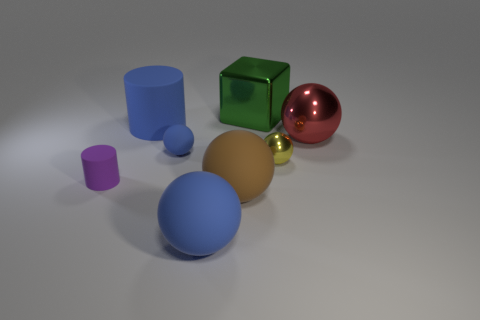There is a cylinder to the right of the purple matte cylinder; is its color the same as the tiny rubber ball?
Provide a short and direct response. Yes. There is a yellow thing that is the same shape as the small blue object; what is its size?
Provide a short and direct response. Small. What color is the big metallic thing that is on the left side of the small ball right of the blue ball in front of the large brown rubber ball?
Keep it short and to the point. Green. Are the brown sphere and the purple cylinder made of the same material?
Ensure brevity in your answer.  Yes. There is a blue sphere that is left of the blue object in front of the tiny blue matte thing; are there any cylinders in front of it?
Your response must be concise. Yes. Is the small rubber ball the same color as the big cylinder?
Offer a terse response. Yes. Is the number of large cubes less than the number of big spheres?
Provide a succinct answer. Yes. Are the blue thing that is behind the red object and the tiny sphere that is on the left side of the green block made of the same material?
Your answer should be very brief. Yes. Is the number of matte things that are right of the metal block less than the number of rubber cylinders?
Offer a terse response. Yes. How many tiny purple rubber objects are behind the metallic sphere to the right of the tiny yellow sphere?
Offer a very short reply. 0. 